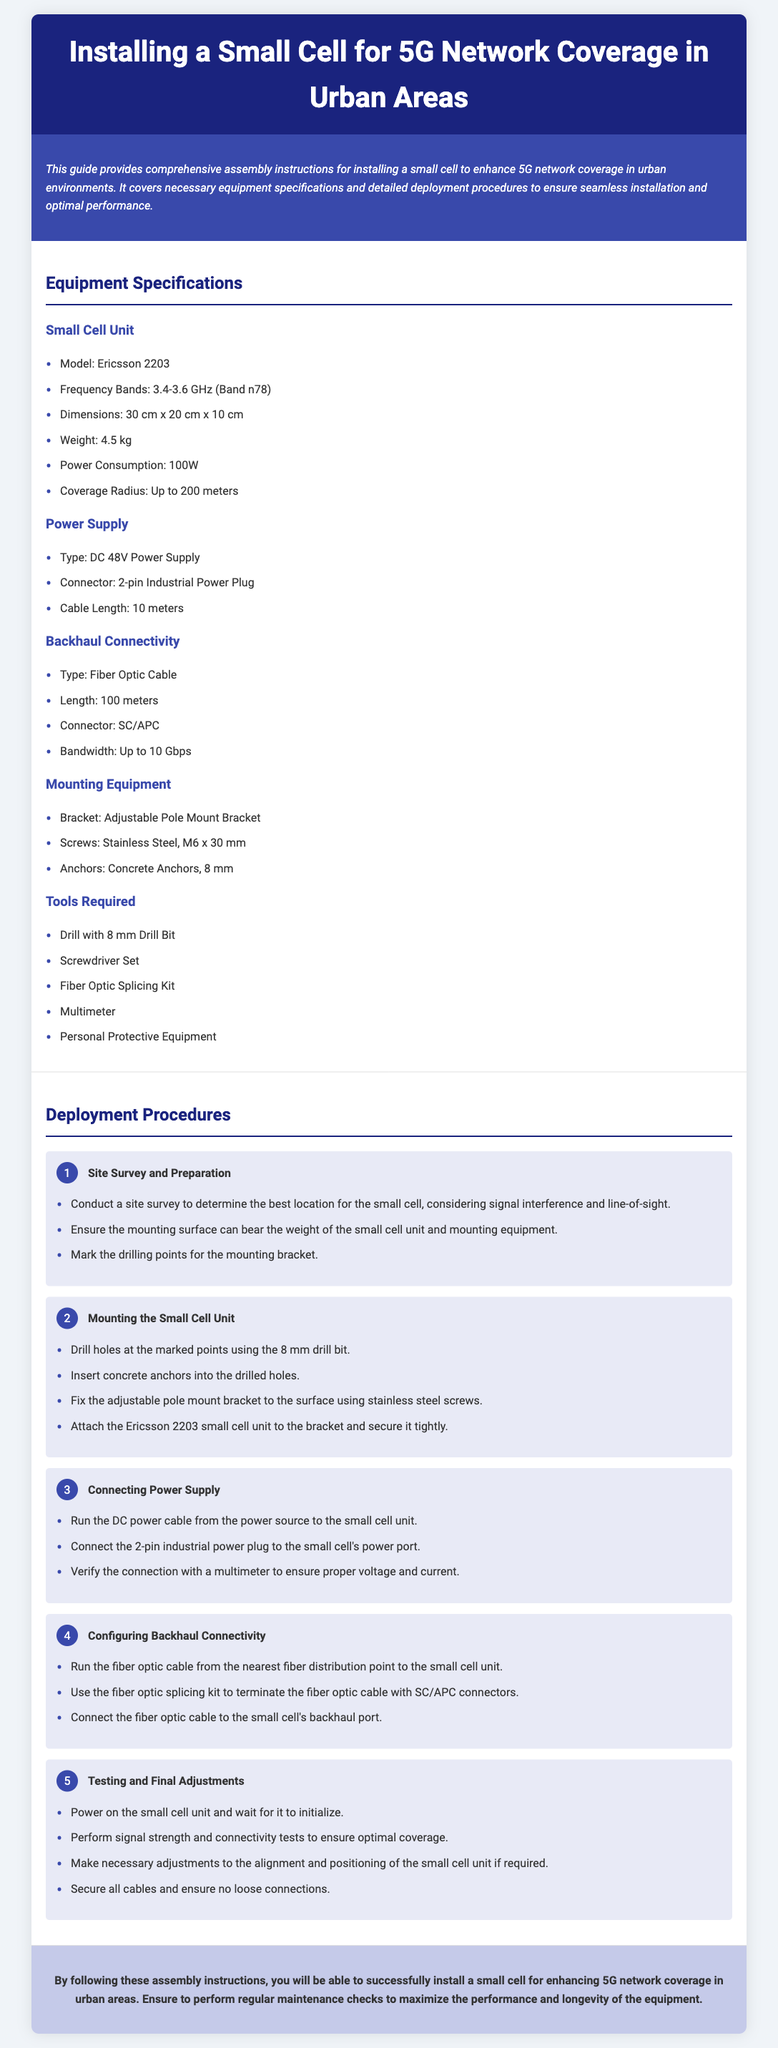What is the model of the small cell unit? The model of the small cell unit is specified in the equipment specifications section as Ericsson 2203.
Answer: Ericsson 2203 What is the power consumption of the Ericsson 2203? Power consumption for the Ericsson 2203 is 100W according to the specifications listed.
Answer: 100W What type of power supply is required? The document specifies that a DC 48V power supply is needed for the small cell installation.
Answer: DC 48V Power Supply What is the coverage radius of the small cell? The coverage radius is given in the equipment specifications section as up to 200 meters.
Answer: Up to 200 meters How far should the fiber optic cable run to connect to the small cell? The required length for the fiber optic cable run is mentioned as 100 meters in the backhaul connectivity section.
Answer: 100 meters How many steps are involved in the deployment procedure? The document lists five main steps involved in the deployment procedures for the small cell installation.
Answer: Five What is the first step in the deployment procedures? The first step in the deployment procedures is conducting a site survey and preparation, as described in the deployment section.
Answer: Site Survey and Preparation What tools are required for the installation? The tools section provides a list that includes a drill with an 8 mm drill bit, a screwdriver set, a fiber optic splicing kit, a multimeter, and personal protective equipment.
Answer: Drill with 8 mm Drill Bit, Screwdriver Set, Fiber Optic Splicing Kit, Multimeter, Personal Protective Equipment What should be done after powering on the small cell unit? After powering on, the document instructs to perform signal strength and connectivity tests to ensure optimal coverage.
Answer: Perform signal strength and connectivity tests 